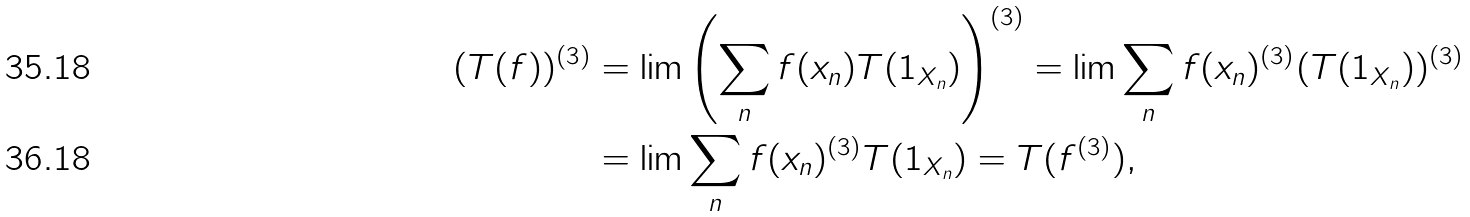<formula> <loc_0><loc_0><loc_500><loc_500>( T ( f ) ) ^ { ( 3 ) } & = \lim \left ( \sum _ { n } f ( x _ { n } ) T ( 1 _ { X _ { n } } ) \right ) ^ { ( 3 ) } = \lim \sum _ { n } f ( x _ { n } ) ^ { ( 3 ) } ( T ( 1 _ { X _ { n } } ) ) ^ { ( 3 ) } \\ & = \lim \sum _ { n } f ( x _ { n } ) ^ { ( 3 ) } T ( 1 _ { X _ { n } } ) = T ( f ^ { ( 3 ) } ) ,</formula> 